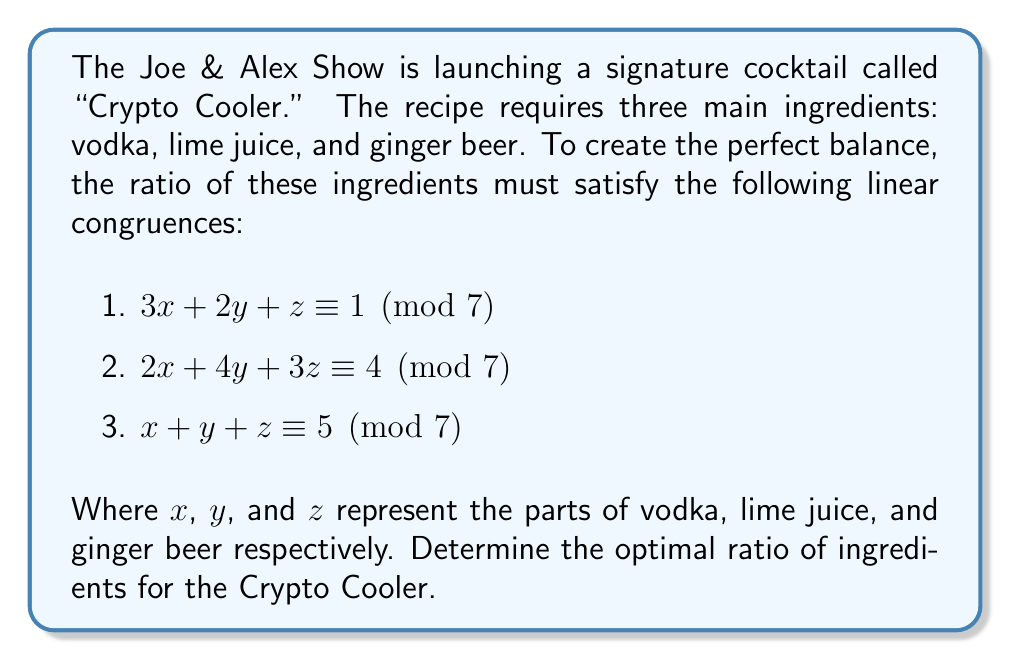Teach me how to tackle this problem. To solve this system of linear congruences, we'll use the Chinese Remainder Theorem approach:

1) First, we need to solve for $x$, $y$, and $z$ modulo 7.

2) We can rewrite the system as:
   $$\begin{cases}
   3x + 2y + z \equiv 1 \pmod{7} \\
   2x + 4y + 3z \equiv 4 \pmod{7} \\
   x + y + z \equiv 5 \pmod{7}
   \end{cases}$$

3) Subtracting the third equation from the first:
   $2x + y \equiv 3 \pmod{7}$

4) Subtracting the third equation from the second:
   $x + 3y + 2z \equiv 6 \pmod{7}$

5) From step 3, we can express $y$ in terms of $x$:
   $y \equiv 3 - 2x \pmod{7}$

6) Substituting this into the equation from step 4:
   $x + 3(3-2x) + 2z \equiv 6 \pmod{7}$
   $x + 9 - 6x + 2z \equiv 6 \pmod{7}$
   $-5x + 2z \equiv 4 \pmod{7}$

7) Multiplying both sides by 3 (the modular multiplicative inverse of 5 mod 7):
   $-15x + 6z \equiv 12 \pmod{7}$
   $-x + 6z \equiv 5 \pmod{7}$
   $6z - x \equiv 5 \pmod{7}$

8) Now we have:
   $$\begin{cases}
   6z - x \equiv 5 \pmod{7} \\
   x + y + z \equiv 5 \pmod{7}
   \end{cases}$$

9) Subtracting the second equation from the first:
   $5z - y \equiv 0 \pmod{7}$
   $5z \equiv y \pmod{7}$

10) Substituting this back into the equation from step 5:
    $5z \equiv 3 - 2x \pmod{7}$
    $5z + 2x \equiv 3 \pmod{7}$

11) Solving this with the equation from step 7:
    $$\begin{cases}
    6z - x \equiv 5 \pmod{7} \\
    5z + 2x \equiv 3 \pmod{7}
    \end{cases}$$

12) Multiplying the second equation by 3 and the first by 2:
    $$\begin{cases}
    12z - 2x \equiv 10 \equiv 3 \pmod{7} \\
    15z + 6x \equiv 9 \equiv 2 \pmod{7}
    \end{cases}$$

13) Adding these equations:
    $27z + 4x \equiv 5 \pmod{7}$
    $-z + 4x \equiv 5 \pmod{7}$
    $4x \equiv z + 5 \pmod{7}$
    $x \equiv 2z + 4 \pmod{7}$

14) Substituting this back into the equation from step 7:
    $6z - (2z + 4) \equiv 5 \pmod{7}$
    $4z - 4 \equiv 5 \pmod{7}$
    $4z \equiv 9 \equiv 2 \pmod{7}$
    $z \equiv 4 \pmod{7}$

15) Now we can find $x$ and $y$:
    $x \equiv 2(4) + 4 \equiv 5 \pmod{7}$
    $y \equiv 3 - 2(5) \equiv 3 \pmod{7}$

Therefore, the optimal ratio is $x:y:z = 5:3:4$.
Answer: 5:3:4 